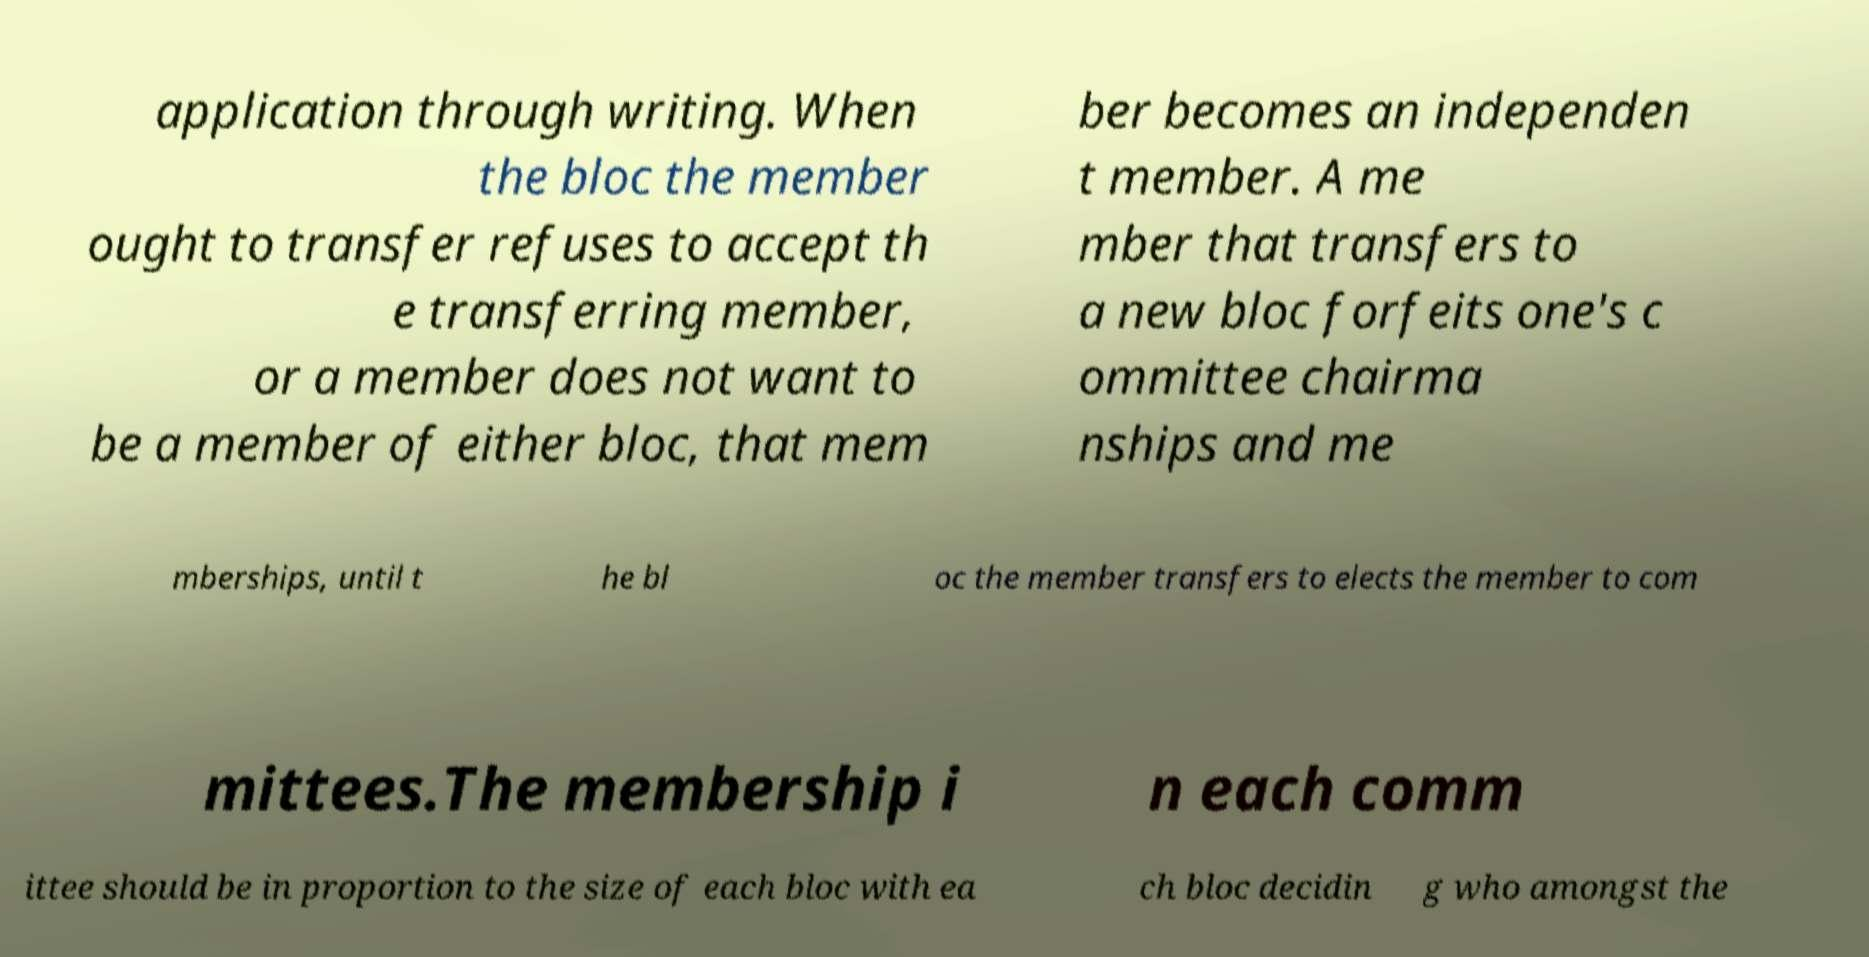Could you assist in decoding the text presented in this image and type it out clearly? application through writing. When the bloc the member ought to transfer refuses to accept th e transferring member, or a member does not want to be a member of either bloc, that mem ber becomes an independen t member. A me mber that transfers to a new bloc forfeits one's c ommittee chairma nships and me mberships, until t he bl oc the member transfers to elects the member to com mittees.The membership i n each comm ittee should be in proportion to the size of each bloc with ea ch bloc decidin g who amongst the 